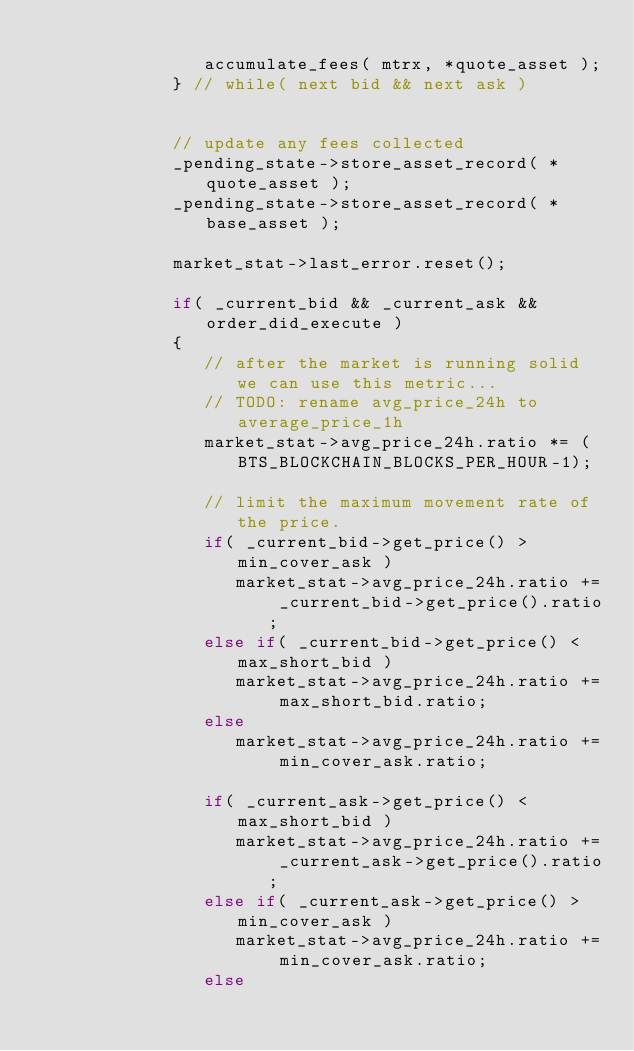Convert code to text. <code><loc_0><loc_0><loc_500><loc_500><_C++_>
                accumulate_fees( mtrx, *quote_asset );
             } // while( next bid && next ask )


             // update any fees collected
             _pending_state->store_asset_record( *quote_asset );
             _pending_state->store_asset_record( *base_asset );

             market_stat->last_error.reset();

             if( _current_bid && _current_ask && order_did_execute )
             {
                // after the market is running solid we can use this metric...
                // TODO: rename avg_price_24h to average_price_1h 
                market_stat->avg_price_24h.ratio *= (BTS_BLOCKCHAIN_BLOCKS_PER_HOUR-1);

                // limit the maximum movement rate of the price.
                if( _current_bid->get_price() > min_cover_ask )
                   market_stat->avg_price_24h.ratio += _current_bid->get_price().ratio;
                else if( _current_bid->get_price() < max_short_bid )
                   market_stat->avg_price_24h.ratio += max_short_bid.ratio;
                else
                   market_stat->avg_price_24h.ratio += min_cover_ask.ratio;

                if( _current_ask->get_price() < max_short_bid )
                   market_stat->avg_price_24h.ratio += _current_ask->get_price().ratio;
                else if( _current_ask->get_price() > min_cover_ask )
                   market_stat->avg_price_24h.ratio += min_cover_ask.ratio;
                else</code> 